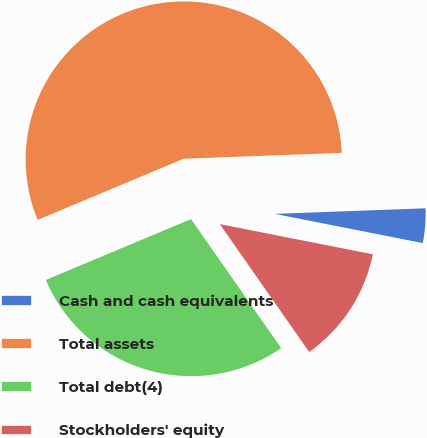Convert chart. <chart><loc_0><loc_0><loc_500><loc_500><pie_chart><fcel>Cash and cash equivalents<fcel>Total assets<fcel>Total debt(4)<fcel>Stockholders' equity<nl><fcel>3.69%<fcel>55.73%<fcel>28.39%<fcel>12.19%<nl></chart> 